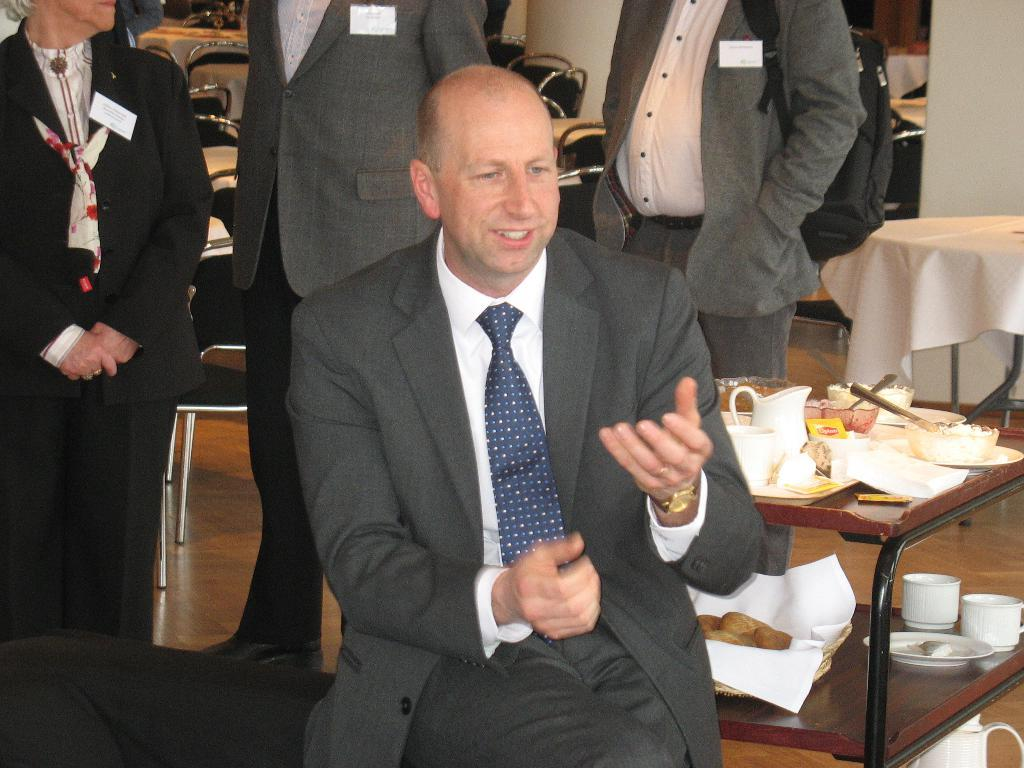What is the position of the person in the image? There is a person sitting in the image. Are there any other people in the image? Yes, there are other people standing behind the sitting person. What furniture can be seen in the image? There is a table and a chair in the image. What items are placed on the table? A water jar, a bowl, and spoons are placed on the table. What type of beef is being served on the table in the image? There is no beef present in the image; the table only has a water jar, a bowl, and spoons. 